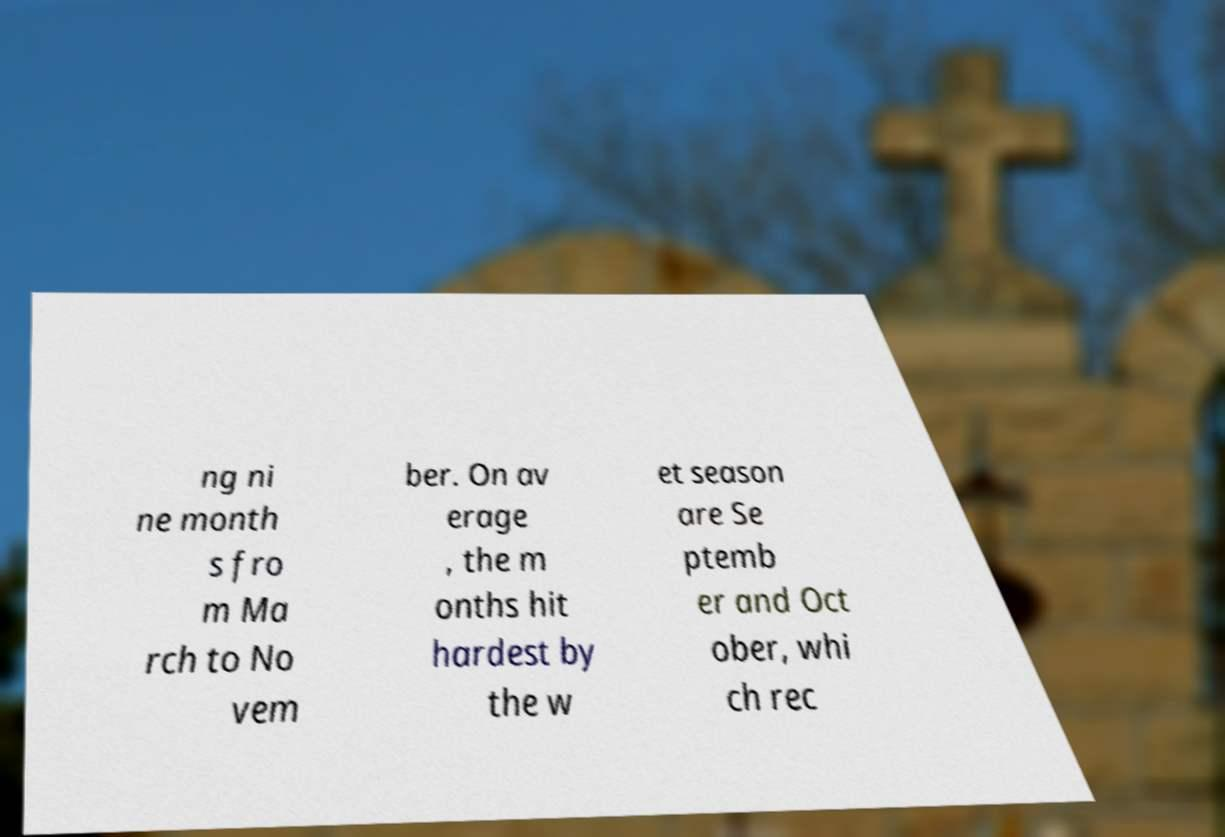What messages or text are displayed in this image? I need them in a readable, typed format. ng ni ne month s fro m Ma rch to No vem ber. On av erage , the m onths hit hardest by the w et season are Se ptemb er and Oct ober, whi ch rec 